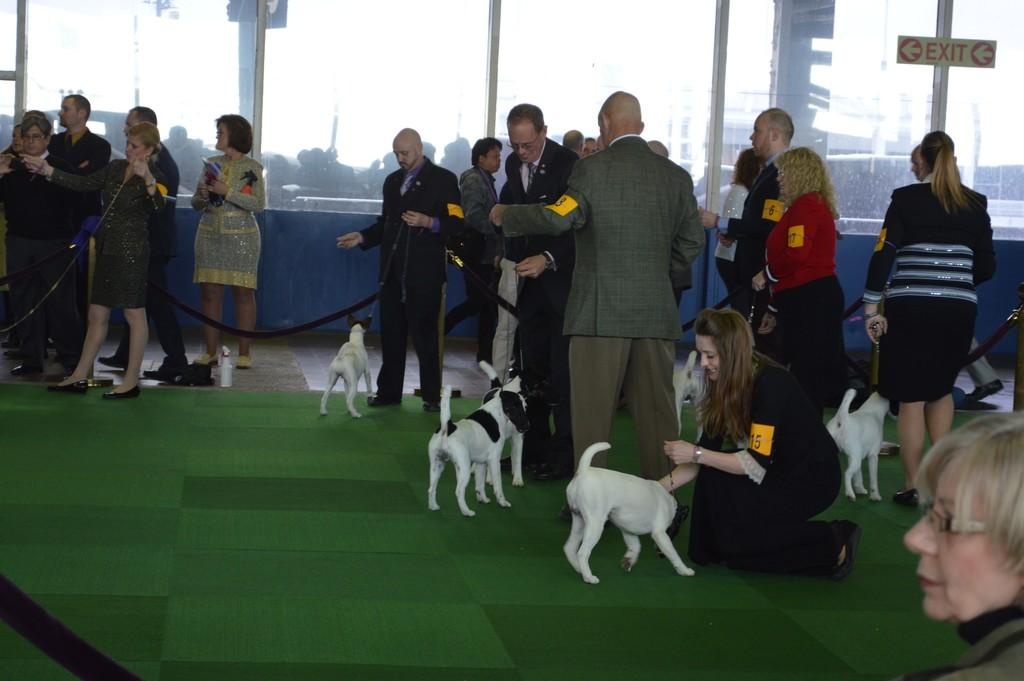Who or what is present in the image? There are people in the image. What are the people doing in the image? The people are standing in the image. What are the people holding in the image? The people are holding dogs in the image. How are the dogs being restrained in the image? The dogs are on chains in the image. What type of bath can be seen in the image? There is no bath present in the image. 